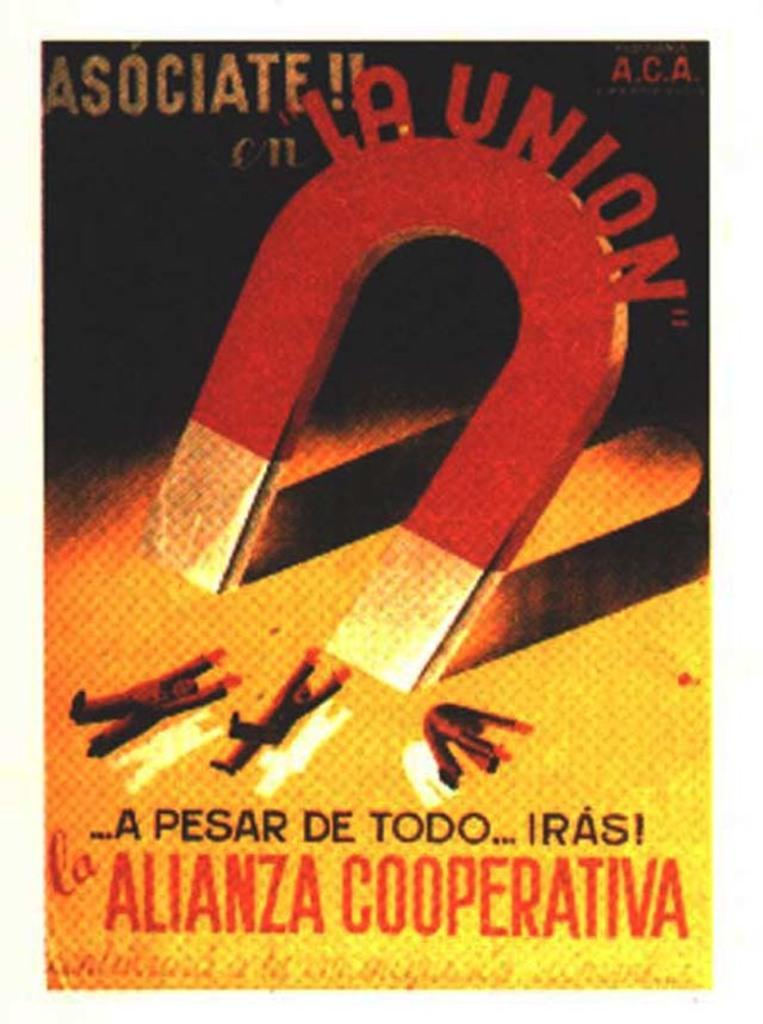<image>
Offer a succinct explanation of the picture presented. A poster of a magnet that says  Alianza cooperativa. 